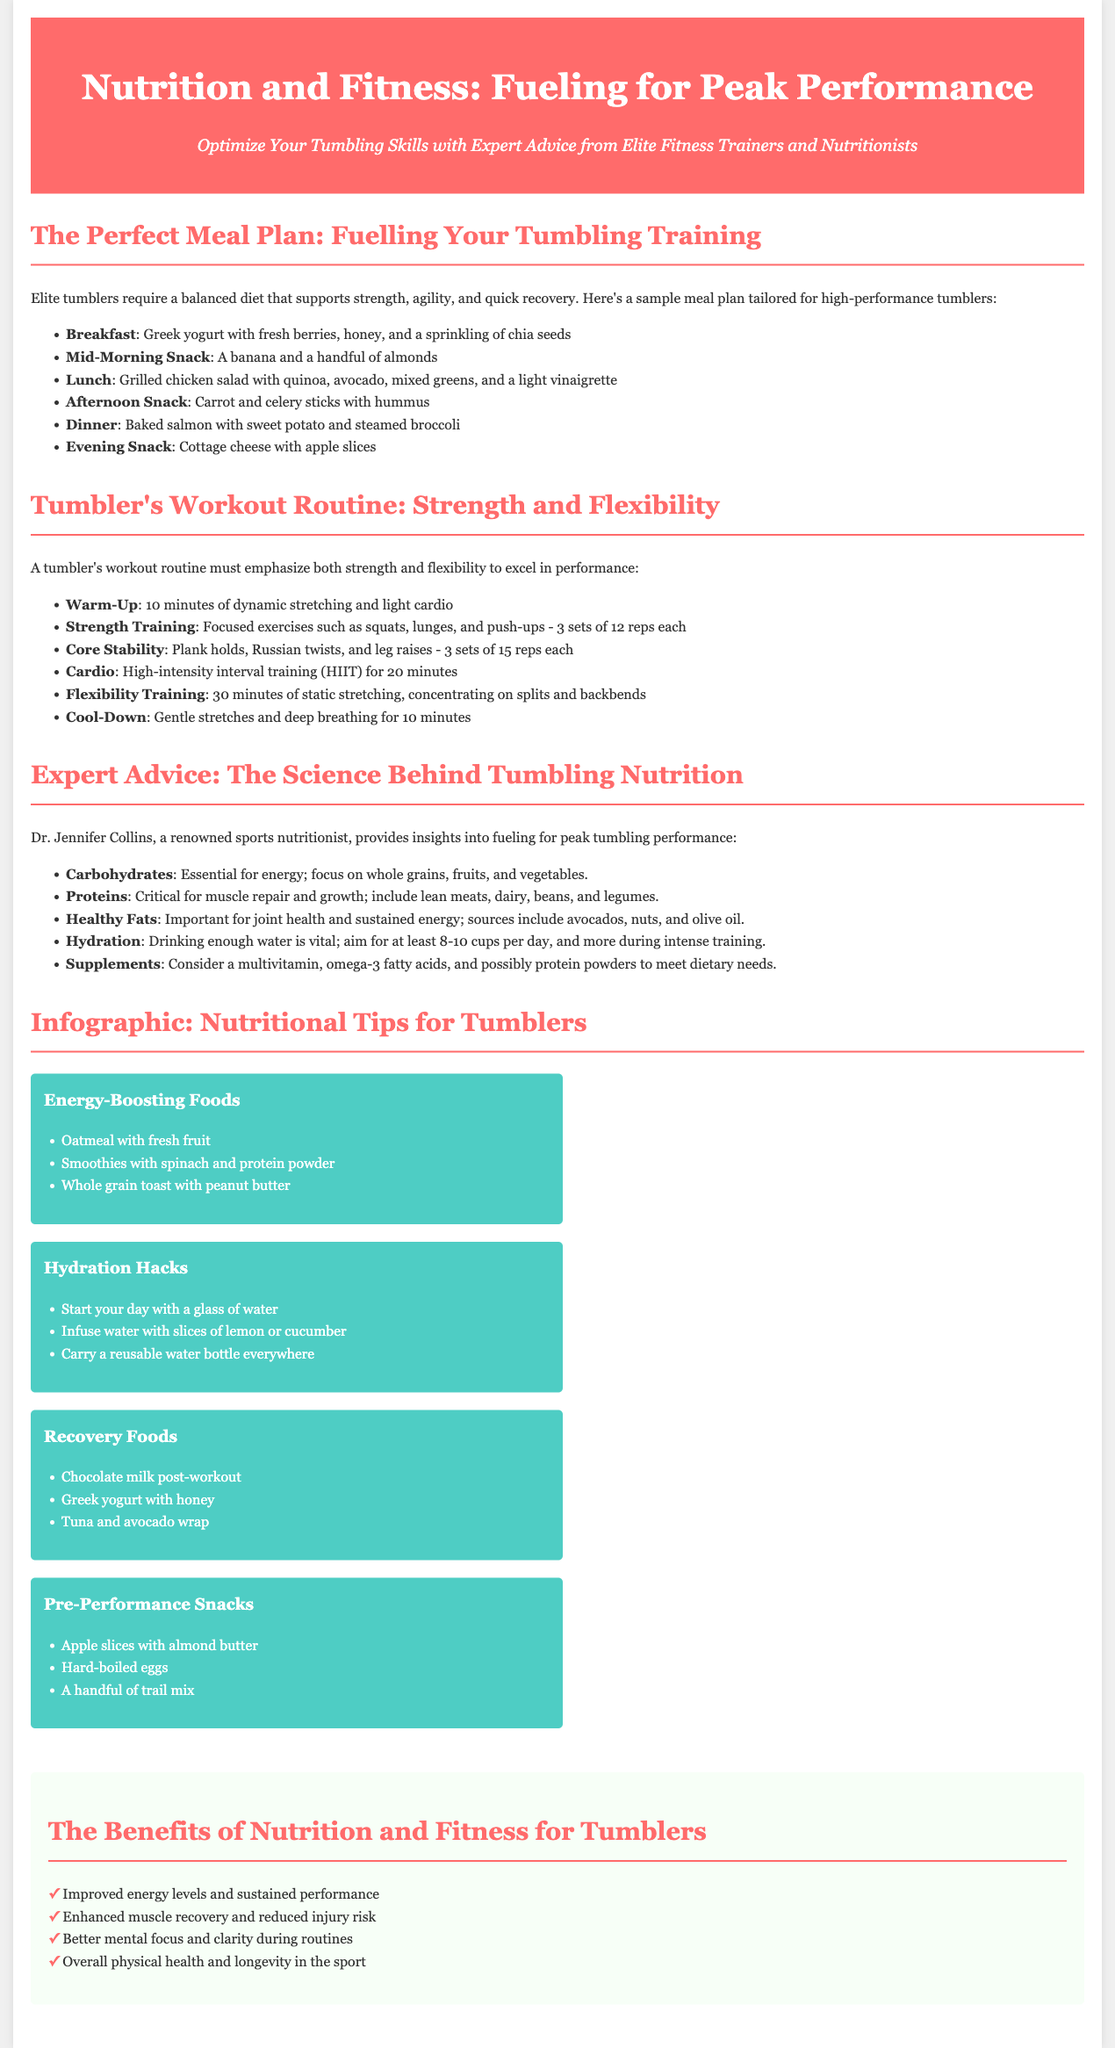What is the title of the article? The title of the article is prominently displayed at the top of the document.
Answer: Nutrition and Fitness: Fueling for Peak Performance Who provides expert advice in the document? The document mentions a specific expert who gives insights on nutrition for tumblers.
Answer: Dr. Jennifer Collins What type of training is emphasized in a tumbler's workout routine? The document states the main focus areas of a tumbler's workout routine.
Answer: Strength and flexibility How many cups of water per day is recommended? The document specifies the minimum daily water intake for hydration.
Answer: 8-10 cups What is listed as a pre-performance snack? The document provides examples of snacks to have before performing.
Answer: Apple slices with almond butter How many sets of 12 reps are suggested for strength training? The document clearly states the number of sets and reps for strength training exercises.
Answer: 3 sets of 12 reps What are the benefits of nutrition mentioned in the document? The document lists several benefits related to nutrition and fitness for tumblers.
Answer: Improved energy levels and sustained performance Which meal includes baked salmon? The document details a meal plan and specifies what is included in the dinner meal.
Answer: Dinner 